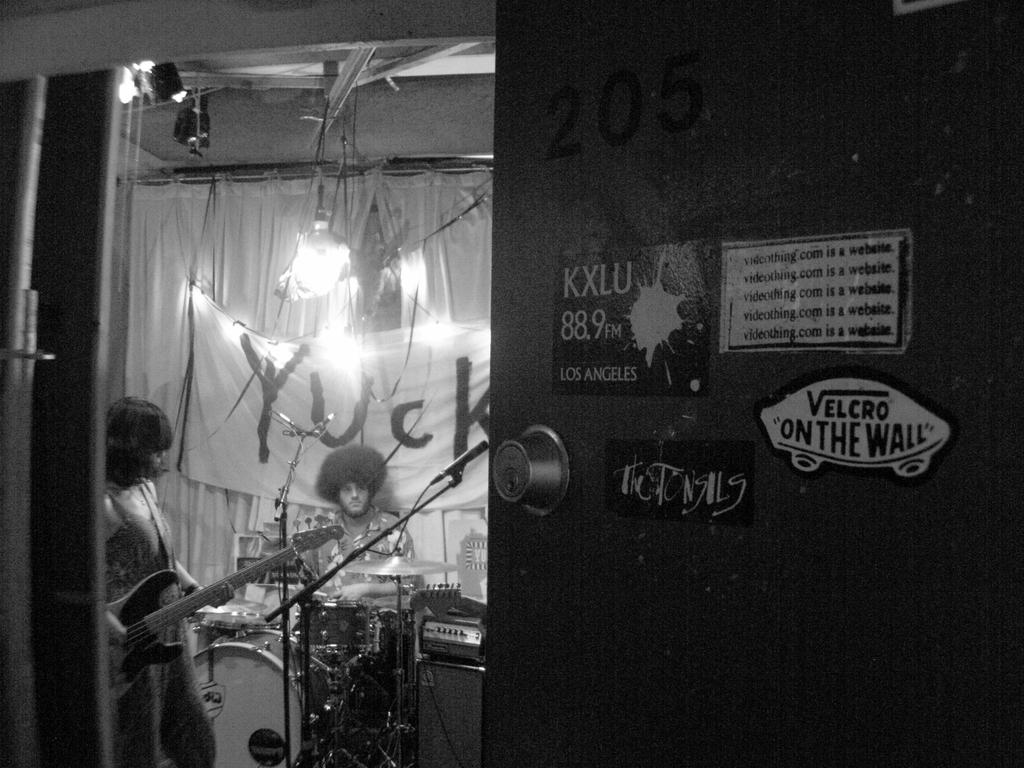What is the color scheme of the image? The image is black and white. What is the man in the image doing? The man is sitting in front of drums. What word is written on the banner in the image? The banner has the word "YUCK" in the image. What instrument is the woman playing in the image? The woman is playing guitar. Can you identify any architectural features in the image? Yes, there is a door visible in the image. What type of flower is growing near the door in the image? There are no flowers present in the image; it is a black and white image with a man sitting in front of drums, a banner with the word "YUCK," a woman playing guitar, and a door visible. Can you describe the sea visible in the background of the image? There is no sea visible in the image; it is an indoor scene with a man sitting in front of drums, a banner with the word "YUCK," a woman playing guitar, and a door visible. 